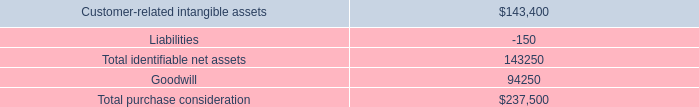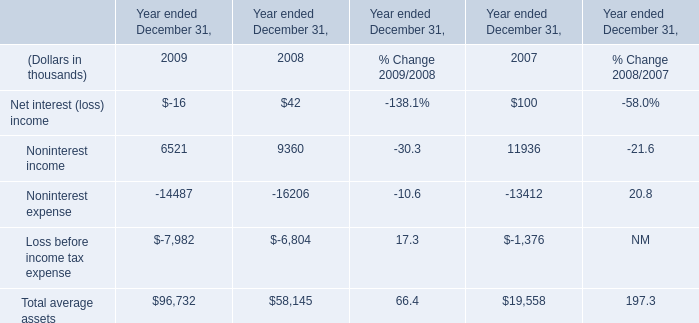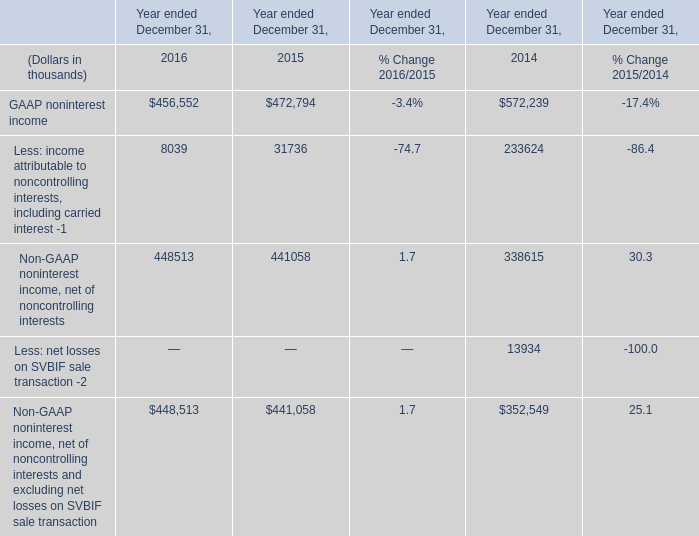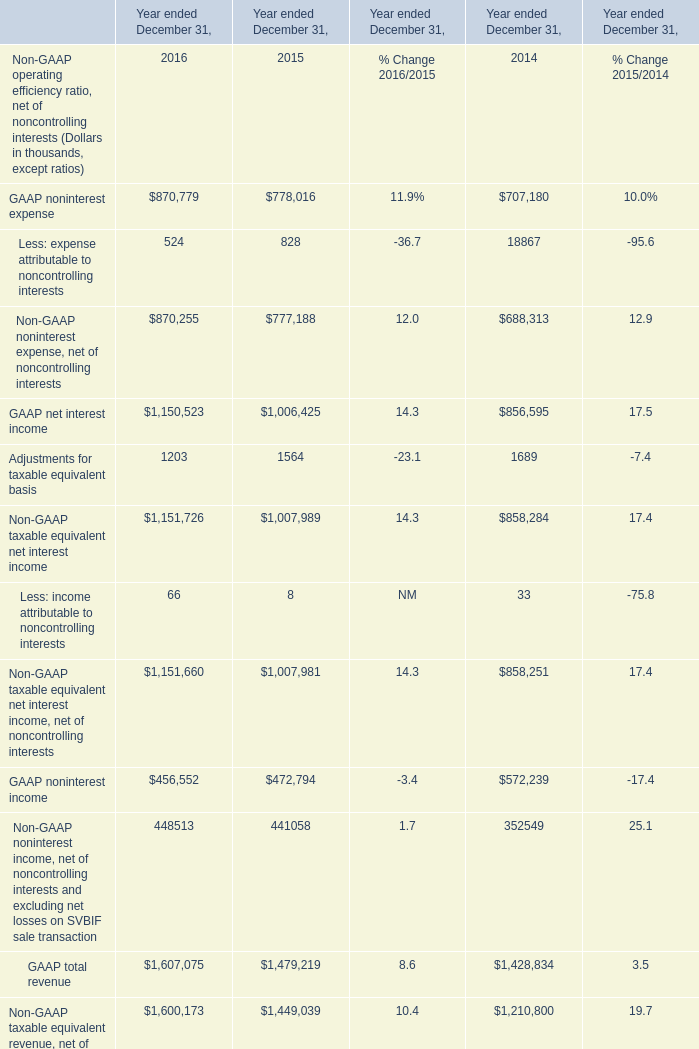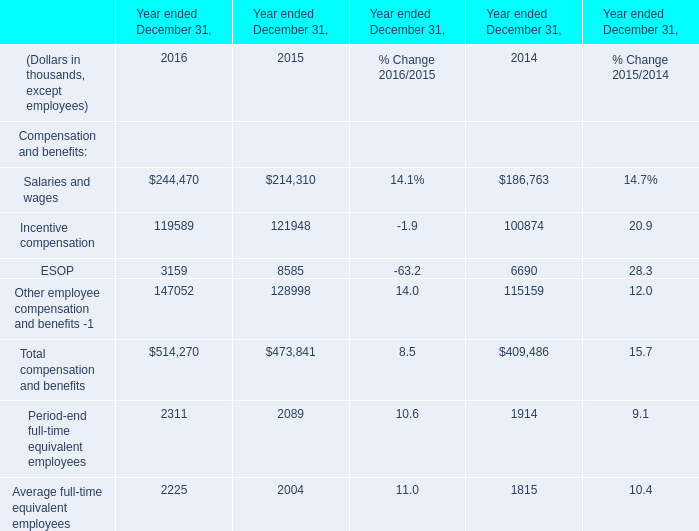What's the average of GAAP net interest income of Year ended December 31, 2016, and Noninterest expense of Year ended December 31, 2009 ? 
Computations: ((1150523.0 + 14487.0) / 2)
Answer: 582505.0. 